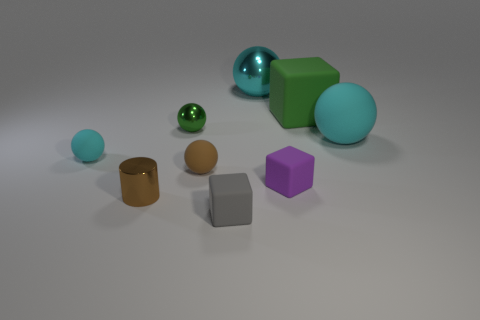Does the brown cylinder have the same size as the cyan ball that is right of the small purple object?
Keep it short and to the point. No. What is the color of the rubber ball that is both on the left side of the green cube and right of the tiny brown shiny cylinder?
Keep it short and to the point. Brown. There is a tiny matte block that is to the left of the purple rubber cube; is there a tiny gray thing right of it?
Make the answer very short. No. Is the number of brown rubber things behind the small green sphere the same as the number of purple blocks?
Keep it short and to the point. No. What number of metal cylinders are in front of the small shiny object that is left of the small metallic object to the right of the small brown metal cylinder?
Ensure brevity in your answer.  0. Are there any gray rubber spheres that have the same size as the purple object?
Provide a succinct answer. No. Are there fewer big green blocks to the right of the big green block than large blocks?
Your answer should be very brief. Yes. There is a big cyan sphere in front of the big cyan ball that is behind the green thing that is on the left side of the gray object; what is it made of?
Offer a very short reply. Rubber. Is the number of matte things in front of the purple object greater than the number of purple rubber cubes that are in front of the brown metallic object?
Make the answer very short. Yes. How many matte objects are large blue objects or small gray cubes?
Keep it short and to the point. 1. 